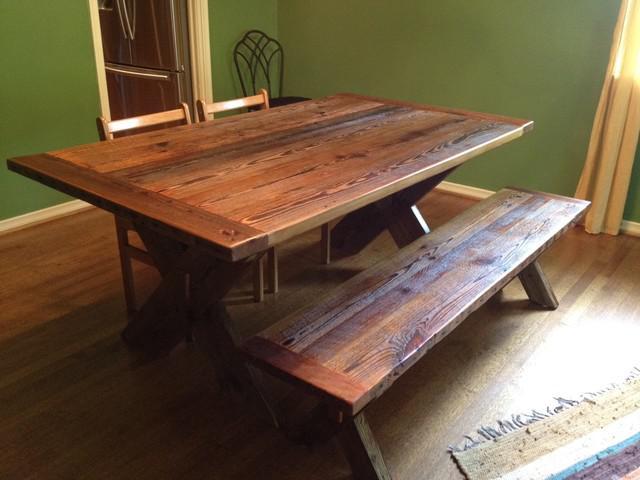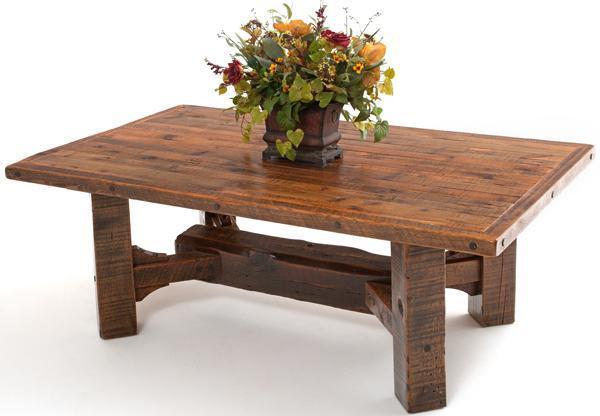The first image is the image on the left, the second image is the image on the right. Given the left and right images, does the statement "there are flowers on the table in the image on the right" hold true? Answer yes or no. Yes. 